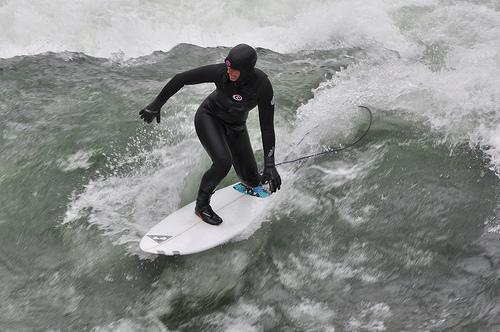How many people in the water?
Give a very brief answer. 1. 